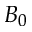Convert formula to latex. <formula><loc_0><loc_0><loc_500><loc_500>B _ { 0 }</formula> 